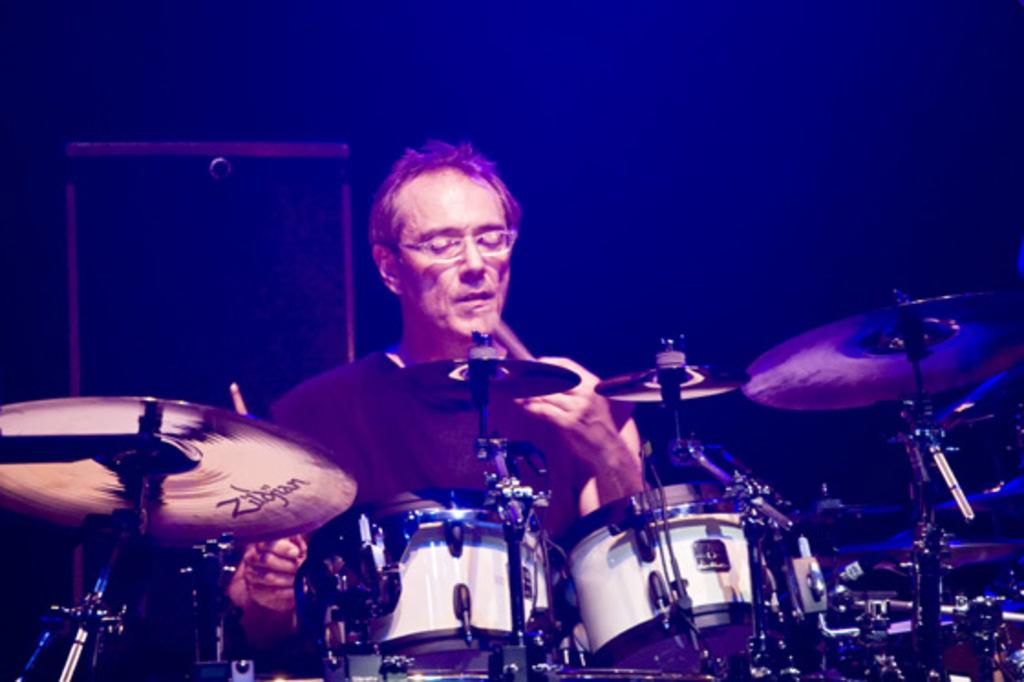What is the main subject of the image? The main subject of the image is a man. What is the man doing in the image? The man is sitting and playing drums. What can be seen behind the man in the image? There are rectangular shape objects behind the man. Where is the man's mom or mother in the image? There is no mention of a mom or mother in the image, and therefore it cannot be determined if they are present. 